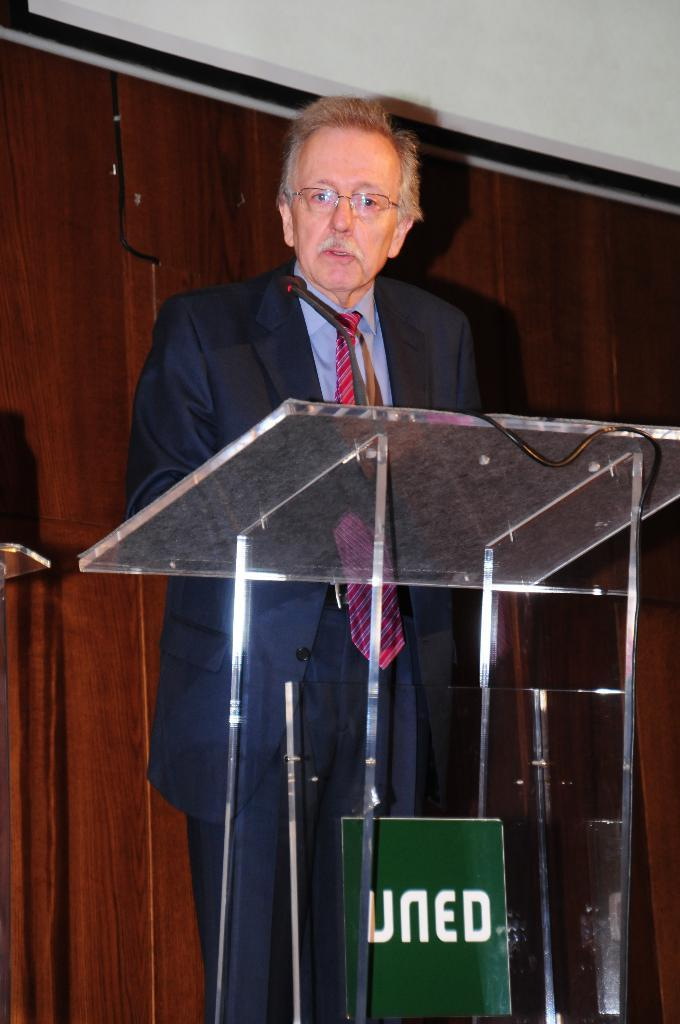What type of furniture is present in the image? There are cupboards in the image. Can you describe the person in the image? There is a man in the image. What is the man wearing in the image? The man is wearing a blue color suit. What type of observation can be made about the structure and wing in the image? There is no mention of a structure or wing in the provided facts, so it is not possible to make any observations about them in the image. 